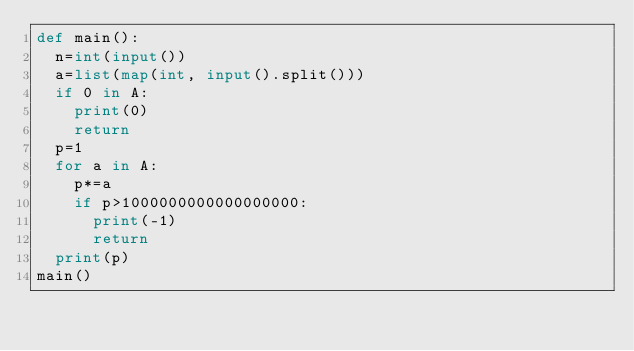Convert code to text. <code><loc_0><loc_0><loc_500><loc_500><_Python_>def main():
  n=int(input())
  a=list(map(int, input().split()))
  if 0 in A:
    print(0)
    return
  p=1
  for a in A:
    p*=a
    if p>1000000000000000000:
      print(-1)
      return
  print(p)
main()
  
</code> 